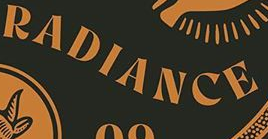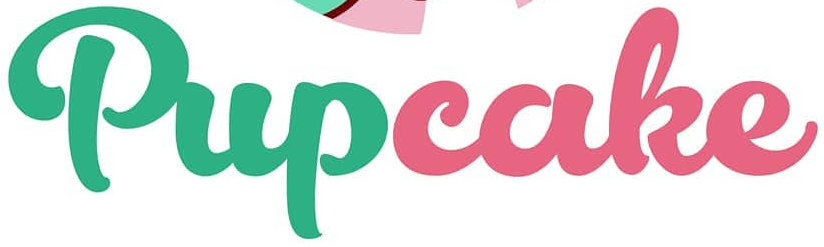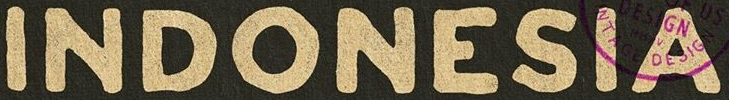Transcribe the words shown in these images in order, separated by a semicolon. RADIANCE; Pupcake; INDONESIA 